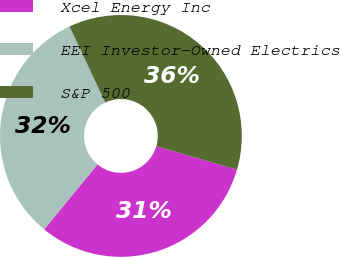Convert chart. <chart><loc_0><loc_0><loc_500><loc_500><pie_chart><fcel>Xcel Energy Inc<fcel>EEI Investor-Owned Electrics<fcel>S&P 500<nl><fcel>31.45%<fcel>32.08%<fcel>36.48%<nl></chart> 